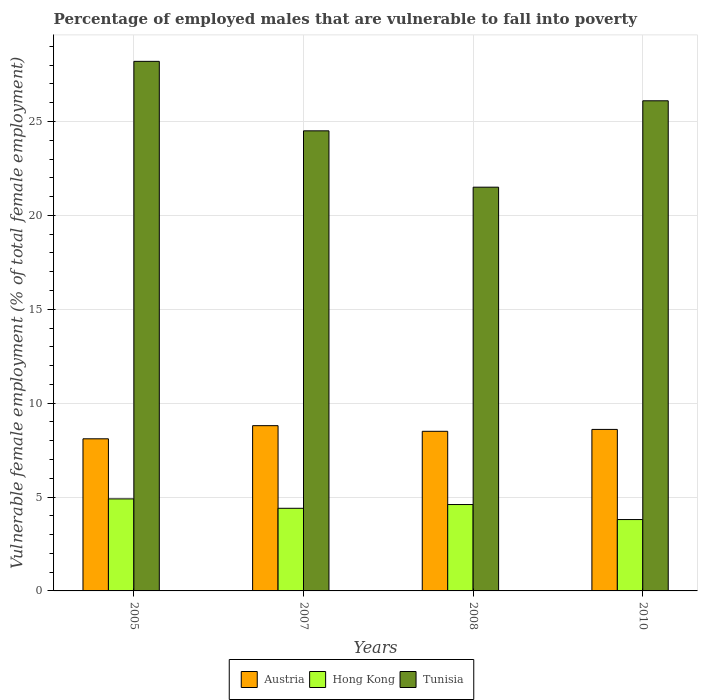How many different coloured bars are there?
Your response must be concise. 3. What is the label of the 2nd group of bars from the left?
Your response must be concise. 2007. In how many cases, is the number of bars for a given year not equal to the number of legend labels?
Ensure brevity in your answer.  0. What is the percentage of employed males who are vulnerable to fall into poverty in Tunisia in 2005?
Give a very brief answer. 28.2. Across all years, what is the maximum percentage of employed males who are vulnerable to fall into poverty in Tunisia?
Offer a terse response. 28.2. Across all years, what is the minimum percentage of employed males who are vulnerable to fall into poverty in Tunisia?
Provide a short and direct response. 21.5. In which year was the percentage of employed males who are vulnerable to fall into poverty in Austria minimum?
Provide a short and direct response. 2005. What is the total percentage of employed males who are vulnerable to fall into poverty in Tunisia in the graph?
Ensure brevity in your answer.  100.3. What is the difference between the percentage of employed males who are vulnerable to fall into poverty in Tunisia in 2007 and that in 2010?
Provide a succinct answer. -1.6. What is the difference between the percentage of employed males who are vulnerable to fall into poverty in Tunisia in 2008 and the percentage of employed males who are vulnerable to fall into poverty in Hong Kong in 2007?
Your answer should be compact. 17.1. What is the average percentage of employed males who are vulnerable to fall into poverty in Hong Kong per year?
Provide a short and direct response. 4.43. In the year 2007, what is the difference between the percentage of employed males who are vulnerable to fall into poverty in Tunisia and percentage of employed males who are vulnerable to fall into poverty in Austria?
Provide a succinct answer. 15.7. In how many years, is the percentage of employed males who are vulnerable to fall into poverty in Hong Kong greater than 21 %?
Offer a very short reply. 0. What is the ratio of the percentage of employed males who are vulnerable to fall into poverty in Tunisia in 2007 to that in 2010?
Your answer should be compact. 0.94. Is the percentage of employed males who are vulnerable to fall into poverty in Austria in 2007 less than that in 2010?
Give a very brief answer. No. What is the difference between the highest and the second highest percentage of employed males who are vulnerable to fall into poverty in Tunisia?
Your answer should be very brief. 2.1. What is the difference between the highest and the lowest percentage of employed males who are vulnerable to fall into poverty in Austria?
Give a very brief answer. 0.7. In how many years, is the percentage of employed males who are vulnerable to fall into poverty in Tunisia greater than the average percentage of employed males who are vulnerable to fall into poverty in Tunisia taken over all years?
Make the answer very short. 2. Is the sum of the percentage of employed males who are vulnerable to fall into poverty in Hong Kong in 2007 and 2008 greater than the maximum percentage of employed males who are vulnerable to fall into poverty in Austria across all years?
Ensure brevity in your answer.  Yes. What does the 3rd bar from the left in 2005 represents?
Give a very brief answer. Tunisia. What does the 2nd bar from the right in 2005 represents?
Your response must be concise. Hong Kong. How many years are there in the graph?
Offer a terse response. 4. What is the difference between two consecutive major ticks on the Y-axis?
Provide a short and direct response. 5. Are the values on the major ticks of Y-axis written in scientific E-notation?
Make the answer very short. No. Does the graph contain any zero values?
Make the answer very short. No. Does the graph contain grids?
Offer a terse response. Yes. How are the legend labels stacked?
Offer a very short reply. Horizontal. What is the title of the graph?
Ensure brevity in your answer.  Percentage of employed males that are vulnerable to fall into poverty. What is the label or title of the Y-axis?
Offer a very short reply. Vulnerable female employment (% of total female employment). What is the Vulnerable female employment (% of total female employment) of Austria in 2005?
Offer a terse response. 8.1. What is the Vulnerable female employment (% of total female employment) of Hong Kong in 2005?
Your answer should be compact. 4.9. What is the Vulnerable female employment (% of total female employment) in Tunisia in 2005?
Make the answer very short. 28.2. What is the Vulnerable female employment (% of total female employment) of Austria in 2007?
Your answer should be very brief. 8.8. What is the Vulnerable female employment (% of total female employment) of Hong Kong in 2007?
Provide a short and direct response. 4.4. What is the Vulnerable female employment (% of total female employment) in Tunisia in 2007?
Ensure brevity in your answer.  24.5. What is the Vulnerable female employment (% of total female employment) of Hong Kong in 2008?
Your answer should be compact. 4.6. What is the Vulnerable female employment (% of total female employment) in Austria in 2010?
Offer a very short reply. 8.6. What is the Vulnerable female employment (% of total female employment) in Hong Kong in 2010?
Provide a short and direct response. 3.8. What is the Vulnerable female employment (% of total female employment) of Tunisia in 2010?
Provide a succinct answer. 26.1. Across all years, what is the maximum Vulnerable female employment (% of total female employment) of Austria?
Keep it short and to the point. 8.8. Across all years, what is the maximum Vulnerable female employment (% of total female employment) in Hong Kong?
Offer a terse response. 4.9. Across all years, what is the maximum Vulnerable female employment (% of total female employment) in Tunisia?
Offer a terse response. 28.2. Across all years, what is the minimum Vulnerable female employment (% of total female employment) in Austria?
Offer a terse response. 8.1. Across all years, what is the minimum Vulnerable female employment (% of total female employment) in Hong Kong?
Offer a terse response. 3.8. What is the total Vulnerable female employment (% of total female employment) of Austria in the graph?
Provide a succinct answer. 34. What is the total Vulnerable female employment (% of total female employment) in Tunisia in the graph?
Provide a short and direct response. 100.3. What is the difference between the Vulnerable female employment (% of total female employment) of Austria in 2005 and that in 2007?
Give a very brief answer. -0.7. What is the difference between the Vulnerable female employment (% of total female employment) in Hong Kong in 2005 and that in 2008?
Provide a short and direct response. 0.3. What is the difference between the Vulnerable female employment (% of total female employment) of Tunisia in 2005 and that in 2008?
Keep it short and to the point. 6.7. What is the difference between the Vulnerable female employment (% of total female employment) of Austria in 2005 and that in 2010?
Your response must be concise. -0.5. What is the difference between the Vulnerable female employment (% of total female employment) in Austria in 2007 and that in 2008?
Make the answer very short. 0.3. What is the difference between the Vulnerable female employment (% of total female employment) in Hong Kong in 2007 and that in 2008?
Make the answer very short. -0.2. What is the difference between the Vulnerable female employment (% of total female employment) in Hong Kong in 2007 and that in 2010?
Offer a very short reply. 0.6. What is the difference between the Vulnerable female employment (% of total female employment) in Hong Kong in 2008 and that in 2010?
Give a very brief answer. 0.8. What is the difference between the Vulnerable female employment (% of total female employment) in Austria in 2005 and the Vulnerable female employment (% of total female employment) in Tunisia in 2007?
Your answer should be very brief. -16.4. What is the difference between the Vulnerable female employment (% of total female employment) in Hong Kong in 2005 and the Vulnerable female employment (% of total female employment) in Tunisia in 2007?
Your answer should be very brief. -19.6. What is the difference between the Vulnerable female employment (% of total female employment) in Austria in 2005 and the Vulnerable female employment (% of total female employment) in Hong Kong in 2008?
Offer a terse response. 3.5. What is the difference between the Vulnerable female employment (% of total female employment) of Hong Kong in 2005 and the Vulnerable female employment (% of total female employment) of Tunisia in 2008?
Your answer should be compact. -16.6. What is the difference between the Vulnerable female employment (% of total female employment) in Austria in 2005 and the Vulnerable female employment (% of total female employment) in Tunisia in 2010?
Ensure brevity in your answer.  -18. What is the difference between the Vulnerable female employment (% of total female employment) in Hong Kong in 2005 and the Vulnerable female employment (% of total female employment) in Tunisia in 2010?
Ensure brevity in your answer.  -21.2. What is the difference between the Vulnerable female employment (% of total female employment) in Austria in 2007 and the Vulnerable female employment (% of total female employment) in Tunisia in 2008?
Keep it short and to the point. -12.7. What is the difference between the Vulnerable female employment (% of total female employment) in Hong Kong in 2007 and the Vulnerable female employment (% of total female employment) in Tunisia in 2008?
Provide a succinct answer. -17.1. What is the difference between the Vulnerable female employment (% of total female employment) of Austria in 2007 and the Vulnerable female employment (% of total female employment) of Tunisia in 2010?
Ensure brevity in your answer.  -17.3. What is the difference between the Vulnerable female employment (% of total female employment) of Hong Kong in 2007 and the Vulnerable female employment (% of total female employment) of Tunisia in 2010?
Your response must be concise. -21.7. What is the difference between the Vulnerable female employment (% of total female employment) in Austria in 2008 and the Vulnerable female employment (% of total female employment) in Hong Kong in 2010?
Your answer should be very brief. 4.7. What is the difference between the Vulnerable female employment (% of total female employment) in Austria in 2008 and the Vulnerable female employment (% of total female employment) in Tunisia in 2010?
Offer a very short reply. -17.6. What is the difference between the Vulnerable female employment (% of total female employment) in Hong Kong in 2008 and the Vulnerable female employment (% of total female employment) in Tunisia in 2010?
Give a very brief answer. -21.5. What is the average Vulnerable female employment (% of total female employment) in Hong Kong per year?
Your answer should be very brief. 4.42. What is the average Vulnerable female employment (% of total female employment) of Tunisia per year?
Provide a short and direct response. 25.07. In the year 2005, what is the difference between the Vulnerable female employment (% of total female employment) in Austria and Vulnerable female employment (% of total female employment) in Tunisia?
Offer a very short reply. -20.1. In the year 2005, what is the difference between the Vulnerable female employment (% of total female employment) of Hong Kong and Vulnerable female employment (% of total female employment) of Tunisia?
Provide a short and direct response. -23.3. In the year 2007, what is the difference between the Vulnerable female employment (% of total female employment) of Austria and Vulnerable female employment (% of total female employment) of Hong Kong?
Offer a terse response. 4.4. In the year 2007, what is the difference between the Vulnerable female employment (% of total female employment) in Austria and Vulnerable female employment (% of total female employment) in Tunisia?
Give a very brief answer. -15.7. In the year 2007, what is the difference between the Vulnerable female employment (% of total female employment) in Hong Kong and Vulnerable female employment (% of total female employment) in Tunisia?
Make the answer very short. -20.1. In the year 2008, what is the difference between the Vulnerable female employment (% of total female employment) of Austria and Vulnerable female employment (% of total female employment) of Hong Kong?
Ensure brevity in your answer.  3.9. In the year 2008, what is the difference between the Vulnerable female employment (% of total female employment) of Austria and Vulnerable female employment (% of total female employment) of Tunisia?
Offer a terse response. -13. In the year 2008, what is the difference between the Vulnerable female employment (% of total female employment) in Hong Kong and Vulnerable female employment (% of total female employment) in Tunisia?
Make the answer very short. -16.9. In the year 2010, what is the difference between the Vulnerable female employment (% of total female employment) in Austria and Vulnerable female employment (% of total female employment) in Hong Kong?
Provide a short and direct response. 4.8. In the year 2010, what is the difference between the Vulnerable female employment (% of total female employment) in Austria and Vulnerable female employment (% of total female employment) in Tunisia?
Provide a succinct answer. -17.5. In the year 2010, what is the difference between the Vulnerable female employment (% of total female employment) of Hong Kong and Vulnerable female employment (% of total female employment) of Tunisia?
Your response must be concise. -22.3. What is the ratio of the Vulnerable female employment (% of total female employment) in Austria in 2005 to that in 2007?
Offer a very short reply. 0.92. What is the ratio of the Vulnerable female employment (% of total female employment) of Hong Kong in 2005 to that in 2007?
Your response must be concise. 1.11. What is the ratio of the Vulnerable female employment (% of total female employment) in Tunisia in 2005 to that in 2007?
Ensure brevity in your answer.  1.15. What is the ratio of the Vulnerable female employment (% of total female employment) of Austria in 2005 to that in 2008?
Ensure brevity in your answer.  0.95. What is the ratio of the Vulnerable female employment (% of total female employment) in Hong Kong in 2005 to that in 2008?
Your answer should be very brief. 1.07. What is the ratio of the Vulnerable female employment (% of total female employment) of Tunisia in 2005 to that in 2008?
Give a very brief answer. 1.31. What is the ratio of the Vulnerable female employment (% of total female employment) of Austria in 2005 to that in 2010?
Provide a succinct answer. 0.94. What is the ratio of the Vulnerable female employment (% of total female employment) in Hong Kong in 2005 to that in 2010?
Your answer should be very brief. 1.29. What is the ratio of the Vulnerable female employment (% of total female employment) in Tunisia in 2005 to that in 2010?
Your answer should be very brief. 1.08. What is the ratio of the Vulnerable female employment (% of total female employment) of Austria in 2007 to that in 2008?
Keep it short and to the point. 1.04. What is the ratio of the Vulnerable female employment (% of total female employment) of Hong Kong in 2007 to that in 2008?
Provide a succinct answer. 0.96. What is the ratio of the Vulnerable female employment (% of total female employment) of Tunisia in 2007 to that in 2008?
Your response must be concise. 1.14. What is the ratio of the Vulnerable female employment (% of total female employment) of Austria in 2007 to that in 2010?
Make the answer very short. 1.02. What is the ratio of the Vulnerable female employment (% of total female employment) of Hong Kong in 2007 to that in 2010?
Ensure brevity in your answer.  1.16. What is the ratio of the Vulnerable female employment (% of total female employment) in Tunisia in 2007 to that in 2010?
Your answer should be compact. 0.94. What is the ratio of the Vulnerable female employment (% of total female employment) in Austria in 2008 to that in 2010?
Keep it short and to the point. 0.99. What is the ratio of the Vulnerable female employment (% of total female employment) in Hong Kong in 2008 to that in 2010?
Provide a short and direct response. 1.21. What is the ratio of the Vulnerable female employment (% of total female employment) of Tunisia in 2008 to that in 2010?
Make the answer very short. 0.82. What is the difference between the highest and the second highest Vulnerable female employment (% of total female employment) in Austria?
Ensure brevity in your answer.  0.2. What is the difference between the highest and the second highest Vulnerable female employment (% of total female employment) in Tunisia?
Offer a very short reply. 2.1. What is the difference between the highest and the lowest Vulnerable female employment (% of total female employment) of Hong Kong?
Keep it short and to the point. 1.1. What is the difference between the highest and the lowest Vulnerable female employment (% of total female employment) in Tunisia?
Keep it short and to the point. 6.7. 